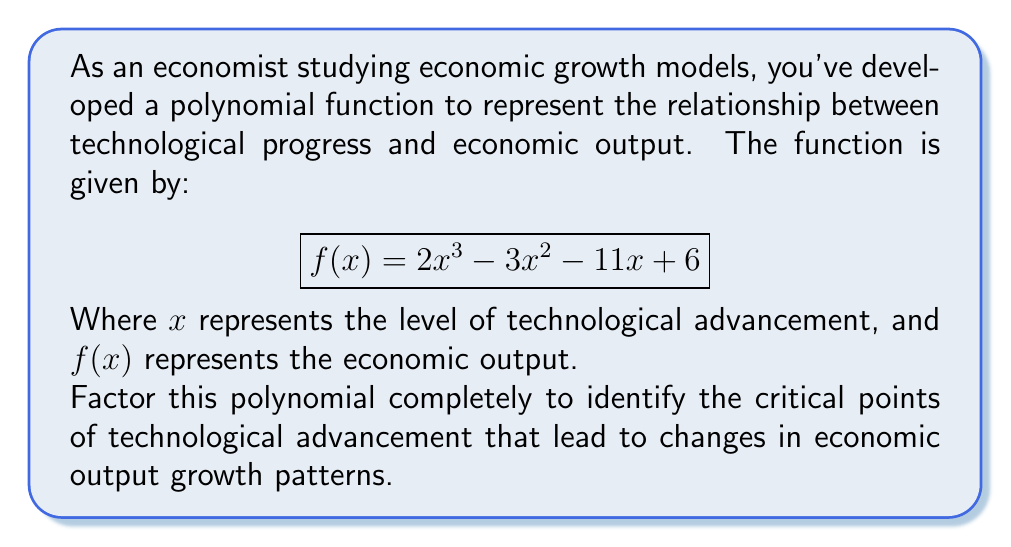Help me with this question. To factor this polynomial, we'll follow these steps:

1) First, let's check if there's a common factor. In this case, there isn't.

2) Next, we'll try to guess one of the factors. A good approach is to look at the possible factors of the constant term (6). The factors of 6 are ±1, ±2, ±3, and ±6. We'll test these as possible roots.

3) Using synthetic division or direct substitution, we find that $x = 1$ is a root:

   $f(1) = 2(1)^3 - 3(1)^2 - 11(1) + 6 = 2 - 3 - 11 + 6 = -6 + 6 = 0$

4) So, $(x - 1)$ is a factor. We can divide $f(x)$ by $(x - 1)$ to get the other factor:

   $$\frac{2x^3 - 3x^2 - 11x + 6}{x - 1} = 2x^2 + x - 6$$

5) Now we need to factor the quadratic $2x^2 + x - 6$. We can do this by finding two numbers that multiply to give $-12$ (the product of $2$ and $-6$) and add to give $1$. These numbers are $3$ and $-2$.

6) So, $2x^2 + x - 6 = (2x - 2)(x + 3) = 2(x - 1)(x + 3)$

Therefore, the complete factorization is:

$$f(x) = (x - 1)(2x - 2)(x + 3) = (x - 1)^2(x + 3)$$

This factorization reveals that the critical points of technological advancement are at $x = 1$ (a double root) and $x = -3$.
Answer: $f(x) = (x - 1)^2(x + 3)$ 